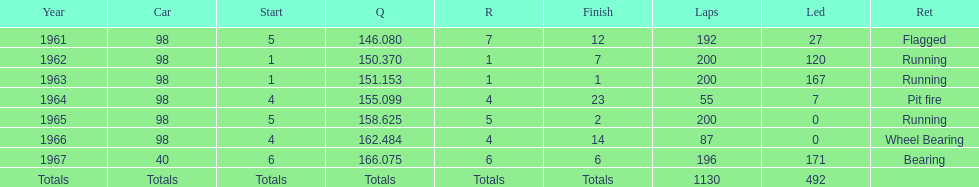In how many indy 500 races, has jones been flagged? 1. 